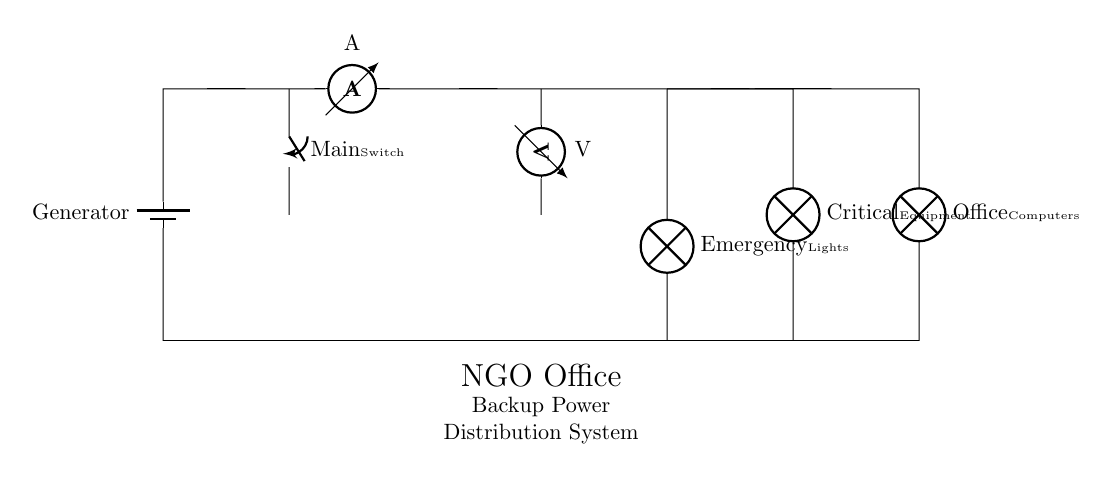What type of circuit is depicted? The circuit shown is a parallel circuit because multiple components are connected across the same voltage source, allowing them to operate independently from each other.
Answer: Parallel circuit What is the role of the generator? The generator functions as the main power source supplying voltage to the entire backup distribution system, powering all the connected components.
Answer: Power source How many lamps are connected in this circuit? There are three lamps connected in parallel, specifically for emergency lights, critical equipment, and office computers, separately drawing power from the circuit.
Answer: Three What is the purpose of the switch? The switch acts as a control mechanism to either allow or interrupt the flow of electricity from the generator to the rest of the circuit, making it essential for operation.
Answer: Control mechanism What is measured by the ammeter? The ammeter measures the current flowing through the circuit, providing an indication of the total current being drawn from the generator to power the connected devices.
Answer: Total current How does the voltage across each lamp compare? In a parallel circuit, the voltage across each lamp is the same as the voltage supplied by the generator, ensuring that all lamps receive equal electrical potential.
Answer: Equal to the generator's voltage 